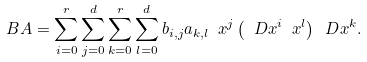Convert formula to latex. <formula><loc_0><loc_0><loc_500><loc_500>B A = \sum _ { i = 0 } ^ { r } \sum _ { j = 0 } ^ { d } \sum _ { k = 0 } ^ { r } \sum _ { l = 0 } ^ { d } b _ { i , j } a _ { k , l } \ x ^ { j } \left ( \ D x ^ { i } \ x ^ { l } \right ) \ D x ^ { k } .</formula> 